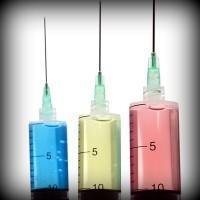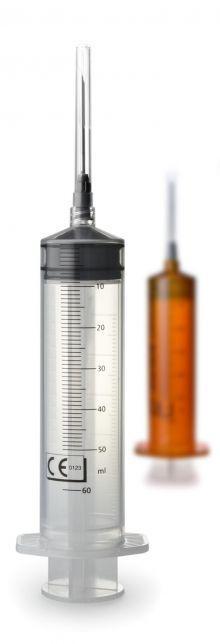The first image is the image on the left, the second image is the image on the right. Given the left and right images, does the statement "The syringe in the right image furthest to the right has a red substance inside it." hold true? Answer yes or no. No. 